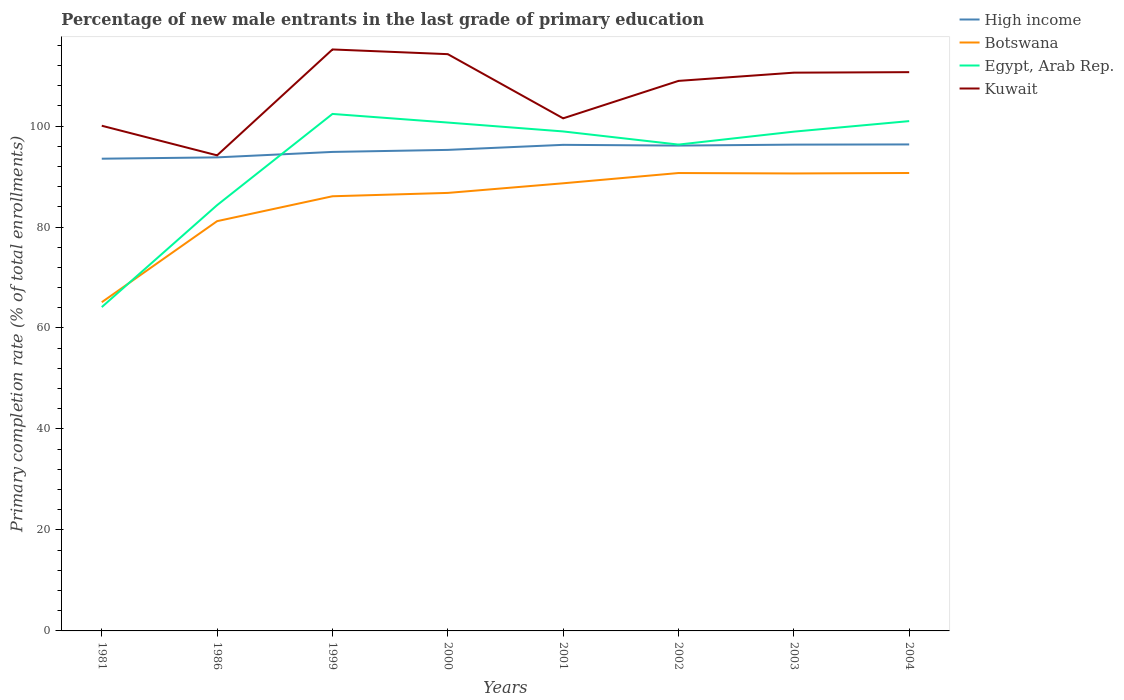How many different coloured lines are there?
Provide a succinct answer. 4. Across all years, what is the maximum percentage of new male entrants in Egypt, Arab Rep.?
Ensure brevity in your answer.  64.14. In which year was the percentage of new male entrants in Egypt, Arab Rep. maximum?
Ensure brevity in your answer.  1981. What is the total percentage of new male entrants in High income in the graph?
Give a very brief answer. -2.33. What is the difference between the highest and the second highest percentage of new male entrants in Egypt, Arab Rep.?
Give a very brief answer. 38.26. Is the percentage of new male entrants in Kuwait strictly greater than the percentage of new male entrants in High income over the years?
Keep it short and to the point. No. How many years are there in the graph?
Offer a very short reply. 8. What is the difference between two consecutive major ticks on the Y-axis?
Provide a short and direct response. 20. Does the graph contain any zero values?
Provide a succinct answer. No. Does the graph contain grids?
Provide a succinct answer. No. Where does the legend appear in the graph?
Provide a succinct answer. Top right. What is the title of the graph?
Make the answer very short. Percentage of new male entrants in the last grade of primary education. Does "Korea (Democratic)" appear as one of the legend labels in the graph?
Offer a terse response. No. What is the label or title of the Y-axis?
Keep it short and to the point. Primary completion rate (% of total enrollments). What is the Primary completion rate (% of total enrollments) in High income in 1981?
Your answer should be compact. 93.53. What is the Primary completion rate (% of total enrollments) of Botswana in 1981?
Your response must be concise. 65.1. What is the Primary completion rate (% of total enrollments) in Egypt, Arab Rep. in 1981?
Your answer should be compact. 64.14. What is the Primary completion rate (% of total enrollments) of Kuwait in 1981?
Provide a succinct answer. 100.06. What is the Primary completion rate (% of total enrollments) in High income in 1986?
Provide a succinct answer. 93.79. What is the Primary completion rate (% of total enrollments) of Botswana in 1986?
Your response must be concise. 81.16. What is the Primary completion rate (% of total enrollments) in Egypt, Arab Rep. in 1986?
Offer a terse response. 84.33. What is the Primary completion rate (% of total enrollments) in Kuwait in 1986?
Give a very brief answer. 94.19. What is the Primary completion rate (% of total enrollments) in High income in 1999?
Provide a succinct answer. 94.87. What is the Primary completion rate (% of total enrollments) in Botswana in 1999?
Keep it short and to the point. 86.09. What is the Primary completion rate (% of total enrollments) of Egypt, Arab Rep. in 1999?
Offer a terse response. 102.39. What is the Primary completion rate (% of total enrollments) of Kuwait in 1999?
Ensure brevity in your answer.  115.16. What is the Primary completion rate (% of total enrollments) of High income in 2000?
Ensure brevity in your answer.  95.27. What is the Primary completion rate (% of total enrollments) of Botswana in 2000?
Give a very brief answer. 86.75. What is the Primary completion rate (% of total enrollments) in Egypt, Arab Rep. in 2000?
Your answer should be compact. 100.69. What is the Primary completion rate (% of total enrollments) in Kuwait in 2000?
Your answer should be very brief. 114.23. What is the Primary completion rate (% of total enrollments) of High income in 2001?
Offer a very short reply. 96.27. What is the Primary completion rate (% of total enrollments) in Botswana in 2001?
Your answer should be compact. 88.66. What is the Primary completion rate (% of total enrollments) in Egypt, Arab Rep. in 2001?
Ensure brevity in your answer.  98.93. What is the Primary completion rate (% of total enrollments) in Kuwait in 2001?
Your response must be concise. 101.52. What is the Primary completion rate (% of total enrollments) in High income in 2002?
Make the answer very short. 96.13. What is the Primary completion rate (% of total enrollments) in Botswana in 2002?
Your answer should be compact. 90.69. What is the Primary completion rate (% of total enrollments) in Egypt, Arab Rep. in 2002?
Your response must be concise. 96.32. What is the Primary completion rate (% of total enrollments) of Kuwait in 2002?
Your answer should be very brief. 108.94. What is the Primary completion rate (% of total enrollments) in High income in 2003?
Provide a succinct answer. 96.32. What is the Primary completion rate (% of total enrollments) of Botswana in 2003?
Your response must be concise. 90.61. What is the Primary completion rate (% of total enrollments) in Egypt, Arab Rep. in 2003?
Provide a short and direct response. 98.89. What is the Primary completion rate (% of total enrollments) in Kuwait in 2003?
Your response must be concise. 110.57. What is the Primary completion rate (% of total enrollments) in High income in 2004?
Ensure brevity in your answer.  96.35. What is the Primary completion rate (% of total enrollments) of Botswana in 2004?
Your response must be concise. 90.7. What is the Primary completion rate (% of total enrollments) in Egypt, Arab Rep. in 2004?
Your answer should be very brief. 100.97. What is the Primary completion rate (% of total enrollments) of Kuwait in 2004?
Your response must be concise. 110.67. Across all years, what is the maximum Primary completion rate (% of total enrollments) in High income?
Ensure brevity in your answer.  96.35. Across all years, what is the maximum Primary completion rate (% of total enrollments) of Botswana?
Your answer should be very brief. 90.7. Across all years, what is the maximum Primary completion rate (% of total enrollments) of Egypt, Arab Rep.?
Give a very brief answer. 102.39. Across all years, what is the maximum Primary completion rate (% of total enrollments) in Kuwait?
Offer a terse response. 115.16. Across all years, what is the minimum Primary completion rate (% of total enrollments) in High income?
Your response must be concise. 93.53. Across all years, what is the minimum Primary completion rate (% of total enrollments) of Botswana?
Offer a very short reply. 65.1. Across all years, what is the minimum Primary completion rate (% of total enrollments) of Egypt, Arab Rep.?
Keep it short and to the point. 64.14. Across all years, what is the minimum Primary completion rate (% of total enrollments) of Kuwait?
Your response must be concise. 94.19. What is the total Primary completion rate (% of total enrollments) in High income in the graph?
Offer a very short reply. 762.53. What is the total Primary completion rate (% of total enrollments) in Botswana in the graph?
Offer a very short reply. 679.75. What is the total Primary completion rate (% of total enrollments) in Egypt, Arab Rep. in the graph?
Keep it short and to the point. 746.66. What is the total Primary completion rate (% of total enrollments) in Kuwait in the graph?
Ensure brevity in your answer.  855.35. What is the difference between the Primary completion rate (% of total enrollments) in High income in 1981 and that in 1986?
Provide a succinct answer. -0.26. What is the difference between the Primary completion rate (% of total enrollments) of Botswana in 1981 and that in 1986?
Make the answer very short. -16.06. What is the difference between the Primary completion rate (% of total enrollments) of Egypt, Arab Rep. in 1981 and that in 1986?
Offer a terse response. -20.2. What is the difference between the Primary completion rate (% of total enrollments) in Kuwait in 1981 and that in 1986?
Provide a succinct answer. 5.86. What is the difference between the Primary completion rate (% of total enrollments) of High income in 1981 and that in 1999?
Offer a terse response. -1.34. What is the difference between the Primary completion rate (% of total enrollments) in Botswana in 1981 and that in 1999?
Ensure brevity in your answer.  -20.99. What is the difference between the Primary completion rate (% of total enrollments) of Egypt, Arab Rep. in 1981 and that in 1999?
Your response must be concise. -38.26. What is the difference between the Primary completion rate (% of total enrollments) in Kuwait in 1981 and that in 1999?
Ensure brevity in your answer.  -15.11. What is the difference between the Primary completion rate (% of total enrollments) of High income in 1981 and that in 2000?
Provide a short and direct response. -1.75. What is the difference between the Primary completion rate (% of total enrollments) in Botswana in 1981 and that in 2000?
Keep it short and to the point. -21.65. What is the difference between the Primary completion rate (% of total enrollments) in Egypt, Arab Rep. in 1981 and that in 2000?
Your response must be concise. -36.55. What is the difference between the Primary completion rate (% of total enrollments) of Kuwait in 1981 and that in 2000?
Keep it short and to the point. -14.18. What is the difference between the Primary completion rate (% of total enrollments) in High income in 1981 and that in 2001?
Ensure brevity in your answer.  -2.74. What is the difference between the Primary completion rate (% of total enrollments) of Botswana in 1981 and that in 2001?
Offer a terse response. -23.55. What is the difference between the Primary completion rate (% of total enrollments) of Egypt, Arab Rep. in 1981 and that in 2001?
Your response must be concise. -34.79. What is the difference between the Primary completion rate (% of total enrollments) of Kuwait in 1981 and that in 2001?
Your answer should be compact. -1.47. What is the difference between the Primary completion rate (% of total enrollments) of High income in 1981 and that in 2002?
Your response must be concise. -2.6. What is the difference between the Primary completion rate (% of total enrollments) of Botswana in 1981 and that in 2002?
Your answer should be very brief. -25.59. What is the difference between the Primary completion rate (% of total enrollments) of Egypt, Arab Rep. in 1981 and that in 2002?
Ensure brevity in your answer.  -32.19. What is the difference between the Primary completion rate (% of total enrollments) in Kuwait in 1981 and that in 2002?
Your answer should be compact. -8.88. What is the difference between the Primary completion rate (% of total enrollments) of High income in 1981 and that in 2003?
Provide a succinct answer. -2.79. What is the difference between the Primary completion rate (% of total enrollments) of Botswana in 1981 and that in 2003?
Make the answer very short. -25.5. What is the difference between the Primary completion rate (% of total enrollments) in Egypt, Arab Rep. in 1981 and that in 2003?
Provide a succinct answer. -34.75. What is the difference between the Primary completion rate (% of total enrollments) of Kuwait in 1981 and that in 2003?
Make the answer very short. -10.51. What is the difference between the Primary completion rate (% of total enrollments) in High income in 1981 and that in 2004?
Keep it short and to the point. -2.82. What is the difference between the Primary completion rate (% of total enrollments) in Botswana in 1981 and that in 2004?
Keep it short and to the point. -25.59. What is the difference between the Primary completion rate (% of total enrollments) in Egypt, Arab Rep. in 1981 and that in 2004?
Your response must be concise. -36.84. What is the difference between the Primary completion rate (% of total enrollments) of Kuwait in 1981 and that in 2004?
Offer a terse response. -10.61. What is the difference between the Primary completion rate (% of total enrollments) of High income in 1986 and that in 1999?
Offer a very short reply. -1.08. What is the difference between the Primary completion rate (% of total enrollments) in Botswana in 1986 and that in 1999?
Provide a short and direct response. -4.93. What is the difference between the Primary completion rate (% of total enrollments) of Egypt, Arab Rep. in 1986 and that in 1999?
Provide a short and direct response. -18.06. What is the difference between the Primary completion rate (% of total enrollments) of Kuwait in 1986 and that in 1999?
Give a very brief answer. -20.97. What is the difference between the Primary completion rate (% of total enrollments) in High income in 1986 and that in 2000?
Your answer should be compact. -1.48. What is the difference between the Primary completion rate (% of total enrollments) in Botswana in 1986 and that in 2000?
Provide a short and direct response. -5.59. What is the difference between the Primary completion rate (% of total enrollments) in Egypt, Arab Rep. in 1986 and that in 2000?
Give a very brief answer. -16.35. What is the difference between the Primary completion rate (% of total enrollments) of Kuwait in 1986 and that in 2000?
Ensure brevity in your answer.  -20.04. What is the difference between the Primary completion rate (% of total enrollments) in High income in 1986 and that in 2001?
Provide a succinct answer. -2.48. What is the difference between the Primary completion rate (% of total enrollments) of Botswana in 1986 and that in 2001?
Offer a terse response. -7.5. What is the difference between the Primary completion rate (% of total enrollments) of Egypt, Arab Rep. in 1986 and that in 2001?
Ensure brevity in your answer.  -14.59. What is the difference between the Primary completion rate (% of total enrollments) in Kuwait in 1986 and that in 2001?
Make the answer very short. -7.33. What is the difference between the Primary completion rate (% of total enrollments) in High income in 1986 and that in 2002?
Your answer should be very brief. -2.33. What is the difference between the Primary completion rate (% of total enrollments) of Botswana in 1986 and that in 2002?
Make the answer very short. -9.53. What is the difference between the Primary completion rate (% of total enrollments) in Egypt, Arab Rep. in 1986 and that in 2002?
Ensure brevity in your answer.  -11.99. What is the difference between the Primary completion rate (% of total enrollments) in Kuwait in 1986 and that in 2002?
Keep it short and to the point. -14.75. What is the difference between the Primary completion rate (% of total enrollments) of High income in 1986 and that in 2003?
Offer a very short reply. -2.52. What is the difference between the Primary completion rate (% of total enrollments) in Botswana in 1986 and that in 2003?
Offer a terse response. -9.45. What is the difference between the Primary completion rate (% of total enrollments) of Egypt, Arab Rep. in 1986 and that in 2003?
Offer a very short reply. -14.55. What is the difference between the Primary completion rate (% of total enrollments) of Kuwait in 1986 and that in 2003?
Make the answer very short. -16.38. What is the difference between the Primary completion rate (% of total enrollments) in High income in 1986 and that in 2004?
Your response must be concise. -2.56. What is the difference between the Primary completion rate (% of total enrollments) in Botswana in 1986 and that in 2004?
Offer a terse response. -9.54. What is the difference between the Primary completion rate (% of total enrollments) in Egypt, Arab Rep. in 1986 and that in 2004?
Offer a very short reply. -16.64. What is the difference between the Primary completion rate (% of total enrollments) of Kuwait in 1986 and that in 2004?
Keep it short and to the point. -16.48. What is the difference between the Primary completion rate (% of total enrollments) in High income in 1999 and that in 2000?
Ensure brevity in your answer.  -0.4. What is the difference between the Primary completion rate (% of total enrollments) of Botswana in 1999 and that in 2000?
Give a very brief answer. -0.66. What is the difference between the Primary completion rate (% of total enrollments) of Egypt, Arab Rep. in 1999 and that in 2000?
Provide a short and direct response. 1.71. What is the difference between the Primary completion rate (% of total enrollments) of Kuwait in 1999 and that in 2000?
Your response must be concise. 0.93. What is the difference between the Primary completion rate (% of total enrollments) of High income in 1999 and that in 2001?
Your response must be concise. -1.4. What is the difference between the Primary completion rate (% of total enrollments) of Botswana in 1999 and that in 2001?
Your answer should be very brief. -2.57. What is the difference between the Primary completion rate (% of total enrollments) in Egypt, Arab Rep. in 1999 and that in 2001?
Keep it short and to the point. 3.47. What is the difference between the Primary completion rate (% of total enrollments) in Kuwait in 1999 and that in 2001?
Provide a succinct answer. 13.64. What is the difference between the Primary completion rate (% of total enrollments) in High income in 1999 and that in 2002?
Make the answer very short. -1.25. What is the difference between the Primary completion rate (% of total enrollments) of Botswana in 1999 and that in 2002?
Provide a short and direct response. -4.6. What is the difference between the Primary completion rate (% of total enrollments) of Egypt, Arab Rep. in 1999 and that in 2002?
Offer a terse response. 6.07. What is the difference between the Primary completion rate (% of total enrollments) in Kuwait in 1999 and that in 2002?
Your answer should be compact. 6.23. What is the difference between the Primary completion rate (% of total enrollments) of High income in 1999 and that in 2003?
Offer a very short reply. -1.45. What is the difference between the Primary completion rate (% of total enrollments) in Botswana in 1999 and that in 2003?
Keep it short and to the point. -4.52. What is the difference between the Primary completion rate (% of total enrollments) in Egypt, Arab Rep. in 1999 and that in 2003?
Your response must be concise. 3.51. What is the difference between the Primary completion rate (% of total enrollments) in Kuwait in 1999 and that in 2003?
Make the answer very short. 4.59. What is the difference between the Primary completion rate (% of total enrollments) of High income in 1999 and that in 2004?
Provide a short and direct response. -1.48. What is the difference between the Primary completion rate (% of total enrollments) in Botswana in 1999 and that in 2004?
Offer a terse response. -4.61. What is the difference between the Primary completion rate (% of total enrollments) of Egypt, Arab Rep. in 1999 and that in 2004?
Offer a terse response. 1.42. What is the difference between the Primary completion rate (% of total enrollments) of Kuwait in 1999 and that in 2004?
Provide a short and direct response. 4.49. What is the difference between the Primary completion rate (% of total enrollments) in High income in 2000 and that in 2001?
Make the answer very short. -1. What is the difference between the Primary completion rate (% of total enrollments) in Botswana in 2000 and that in 2001?
Make the answer very short. -1.91. What is the difference between the Primary completion rate (% of total enrollments) of Egypt, Arab Rep. in 2000 and that in 2001?
Make the answer very short. 1.76. What is the difference between the Primary completion rate (% of total enrollments) of Kuwait in 2000 and that in 2001?
Ensure brevity in your answer.  12.71. What is the difference between the Primary completion rate (% of total enrollments) in High income in 2000 and that in 2002?
Your answer should be very brief. -0.85. What is the difference between the Primary completion rate (% of total enrollments) in Botswana in 2000 and that in 2002?
Ensure brevity in your answer.  -3.94. What is the difference between the Primary completion rate (% of total enrollments) in Egypt, Arab Rep. in 2000 and that in 2002?
Keep it short and to the point. 4.36. What is the difference between the Primary completion rate (% of total enrollments) of Kuwait in 2000 and that in 2002?
Offer a very short reply. 5.29. What is the difference between the Primary completion rate (% of total enrollments) of High income in 2000 and that in 2003?
Give a very brief answer. -1.04. What is the difference between the Primary completion rate (% of total enrollments) in Botswana in 2000 and that in 2003?
Your answer should be compact. -3.86. What is the difference between the Primary completion rate (% of total enrollments) of Egypt, Arab Rep. in 2000 and that in 2003?
Your answer should be very brief. 1.8. What is the difference between the Primary completion rate (% of total enrollments) of Kuwait in 2000 and that in 2003?
Keep it short and to the point. 3.66. What is the difference between the Primary completion rate (% of total enrollments) of High income in 2000 and that in 2004?
Keep it short and to the point. -1.08. What is the difference between the Primary completion rate (% of total enrollments) in Botswana in 2000 and that in 2004?
Offer a terse response. -3.94. What is the difference between the Primary completion rate (% of total enrollments) in Egypt, Arab Rep. in 2000 and that in 2004?
Ensure brevity in your answer.  -0.29. What is the difference between the Primary completion rate (% of total enrollments) of Kuwait in 2000 and that in 2004?
Keep it short and to the point. 3.56. What is the difference between the Primary completion rate (% of total enrollments) in High income in 2001 and that in 2002?
Ensure brevity in your answer.  0.15. What is the difference between the Primary completion rate (% of total enrollments) of Botswana in 2001 and that in 2002?
Offer a very short reply. -2.03. What is the difference between the Primary completion rate (% of total enrollments) of Egypt, Arab Rep. in 2001 and that in 2002?
Offer a terse response. 2.6. What is the difference between the Primary completion rate (% of total enrollments) in Kuwait in 2001 and that in 2002?
Make the answer very short. -7.42. What is the difference between the Primary completion rate (% of total enrollments) in High income in 2001 and that in 2003?
Offer a terse response. -0.04. What is the difference between the Primary completion rate (% of total enrollments) of Botswana in 2001 and that in 2003?
Provide a short and direct response. -1.95. What is the difference between the Primary completion rate (% of total enrollments) in Egypt, Arab Rep. in 2001 and that in 2003?
Provide a short and direct response. 0.04. What is the difference between the Primary completion rate (% of total enrollments) of Kuwait in 2001 and that in 2003?
Ensure brevity in your answer.  -9.05. What is the difference between the Primary completion rate (% of total enrollments) of High income in 2001 and that in 2004?
Your answer should be very brief. -0.08. What is the difference between the Primary completion rate (% of total enrollments) in Botswana in 2001 and that in 2004?
Ensure brevity in your answer.  -2.04. What is the difference between the Primary completion rate (% of total enrollments) in Egypt, Arab Rep. in 2001 and that in 2004?
Give a very brief answer. -2.05. What is the difference between the Primary completion rate (% of total enrollments) of Kuwait in 2001 and that in 2004?
Offer a very short reply. -9.15. What is the difference between the Primary completion rate (% of total enrollments) in High income in 2002 and that in 2003?
Your answer should be very brief. -0.19. What is the difference between the Primary completion rate (% of total enrollments) in Botswana in 2002 and that in 2003?
Your answer should be compact. 0.08. What is the difference between the Primary completion rate (% of total enrollments) in Egypt, Arab Rep. in 2002 and that in 2003?
Your answer should be compact. -2.56. What is the difference between the Primary completion rate (% of total enrollments) in Kuwait in 2002 and that in 2003?
Offer a terse response. -1.63. What is the difference between the Primary completion rate (% of total enrollments) in High income in 2002 and that in 2004?
Ensure brevity in your answer.  -0.23. What is the difference between the Primary completion rate (% of total enrollments) in Botswana in 2002 and that in 2004?
Keep it short and to the point. -0.01. What is the difference between the Primary completion rate (% of total enrollments) of Egypt, Arab Rep. in 2002 and that in 2004?
Make the answer very short. -4.65. What is the difference between the Primary completion rate (% of total enrollments) in Kuwait in 2002 and that in 2004?
Your answer should be very brief. -1.73. What is the difference between the Primary completion rate (% of total enrollments) in High income in 2003 and that in 2004?
Provide a short and direct response. -0.04. What is the difference between the Primary completion rate (% of total enrollments) in Botswana in 2003 and that in 2004?
Your response must be concise. -0.09. What is the difference between the Primary completion rate (% of total enrollments) of Egypt, Arab Rep. in 2003 and that in 2004?
Provide a short and direct response. -2.09. What is the difference between the Primary completion rate (% of total enrollments) in Kuwait in 2003 and that in 2004?
Your answer should be very brief. -0.1. What is the difference between the Primary completion rate (% of total enrollments) in High income in 1981 and the Primary completion rate (% of total enrollments) in Botswana in 1986?
Give a very brief answer. 12.37. What is the difference between the Primary completion rate (% of total enrollments) in High income in 1981 and the Primary completion rate (% of total enrollments) in Egypt, Arab Rep. in 1986?
Keep it short and to the point. 9.2. What is the difference between the Primary completion rate (% of total enrollments) of High income in 1981 and the Primary completion rate (% of total enrollments) of Kuwait in 1986?
Your answer should be very brief. -0.66. What is the difference between the Primary completion rate (% of total enrollments) of Botswana in 1981 and the Primary completion rate (% of total enrollments) of Egypt, Arab Rep. in 1986?
Your response must be concise. -19.23. What is the difference between the Primary completion rate (% of total enrollments) of Botswana in 1981 and the Primary completion rate (% of total enrollments) of Kuwait in 1986?
Give a very brief answer. -29.09. What is the difference between the Primary completion rate (% of total enrollments) of Egypt, Arab Rep. in 1981 and the Primary completion rate (% of total enrollments) of Kuwait in 1986?
Your answer should be compact. -30.06. What is the difference between the Primary completion rate (% of total enrollments) of High income in 1981 and the Primary completion rate (% of total enrollments) of Botswana in 1999?
Keep it short and to the point. 7.44. What is the difference between the Primary completion rate (% of total enrollments) in High income in 1981 and the Primary completion rate (% of total enrollments) in Egypt, Arab Rep. in 1999?
Your response must be concise. -8.86. What is the difference between the Primary completion rate (% of total enrollments) in High income in 1981 and the Primary completion rate (% of total enrollments) in Kuwait in 1999?
Provide a short and direct response. -21.64. What is the difference between the Primary completion rate (% of total enrollments) of Botswana in 1981 and the Primary completion rate (% of total enrollments) of Egypt, Arab Rep. in 1999?
Give a very brief answer. -37.29. What is the difference between the Primary completion rate (% of total enrollments) of Botswana in 1981 and the Primary completion rate (% of total enrollments) of Kuwait in 1999?
Make the answer very short. -50.06. What is the difference between the Primary completion rate (% of total enrollments) of Egypt, Arab Rep. in 1981 and the Primary completion rate (% of total enrollments) of Kuwait in 1999?
Offer a very short reply. -51.03. What is the difference between the Primary completion rate (% of total enrollments) of High income in 1981 and the Primary completion rate (% of total enrollments) of Botswana in 2000?
Your answer should be very brief. 6.78. What is the difference between the Primary completion rate (% of total enrollments) in High income in 1981 and the Primary completion rate (% of total enrollments) in Egypt, Arab Rep. in 2000?
Give a very brief answer. -7.16. What is the difference between the Primary completion rate (% of total enrollments) in High income in 1981 and the Primary completion rate (% of total enrollments) in Kuwait in 2000?
Provide a succinct answer. -20.7. What is the difference between the Primary completion rate (% of total enrollments) of Botswana in 1981 and the Primary completion rate (% of total enrollments) of Egypt, Arab Rep. in 2000?
Offer a terse response. -35.59. What is the difference between the Primary completion rate (% of total enrollments) of Botswana in 1981 and the Primary completion rate (% of total enrollments) of Kuwait in 2000?
Offer a terse response. -49.13. What is the difference between the Primary completion rate (% of total enrollments) of Egypt, Arab Rep. in 1981 and the Primary completion rate (% of total enrollments) of Kuwait in 2000?
Offer a terse response. -50.1. What is the difference between the Primary completion rate (% of total enrollments) of High income in 1981 and the Primary completion rate (% of total enrollments) of Botswana in 2001?
Keep it short and to the point. 4.87. What is the difference between the Primary completion rate (% of total enrollments) of High income in 1981 and the Primary completion rate (% of total enrollments) of Egypt, Arab Rep. in 2001?
Your answer should be very brief. -5.4. What is the difference between the Primary completion rate (% of total enrollments) in High income in 1981 and the Primary completion rate (% of total enrollments) in Kuwait in 2001?
Provide a short and direct response. -7.99. What is the difference between the Primary completion rate (% of total enrollments) of Botswana in 1981 and the Primary completion rate (% of total enrollments) of Egypt, Arab Rep. in 2001?
Give a very brief answer. -33.82. What is the difference between the Primary completion rate (% of total enrollments) of Botswana in 1981 and the Primary completion rate (% of total enrollments) of Kuwait in 2001?
Offer a terse response. -36.42. What is the difference between the Primary completion rate (% of total enrollments) in Egypt, Arab Rep. in 1981 and the Primary completion rate (% of total enrollments) in Kuwait in 2001?
Ensure brevity in your answer.  -37.39. What is the difference between the Primary completion rate (% of total enrollments) in High income in 1981 and the Primary completion rate (% of total enrollments) in Botswana in 2002?
Offer a terse response. 2.84. What is the difference between the Primary completion rate (% of total enrollments) in High income in 1981 and the Primary completion rate (% of total enrollments) in Egypt, Arab Rep. in 2002?
Your answer should be compact. -2.79. What is the difference between the Primary completion rate (% of total enrollments) in High income in 1981 and the Primary completion rate (% of total enrollments) in Kuwait in 2002?
Give a very brief answer. -15.41. What is the difference between the Primary completion rate (% of total enrollments) in Botswana in 1981 and the Primary completion rate (% of total enrollments) in Egypt, Arab Rep. in 2002?
Make the answer very short. -31.22. What is the difference between the Primary completion rate (% of total enrollments) of Botswana in 1981 and the Primary completion rate (% of total enrollments) of Kuwait in 2002?
Keep it short and to the point. -43.84. What is the difference between the Primary completion rate (% of total enrollments) of Egypt, Arab Rep. in 1981 and the Primary completion rate (% of total enrollments) of Kuwait in 2002?
Keep it short and to the point. -44.8. What is the difference between the Primary completion rate (% of total enrollments) in High income in 1981 and the Primary completion rate (% of total enrollments) in Botswana in 2003?
Keep it short and to the point. 2.92. What is the difference between the Primary completion rate (% of total enrollments) in High income in 1981 and the Primary completion rate (% of total enrollments) in Egypt, Arab Rep. in 2003?
Your answer should be very brief. -5.36. What is the difference between the Primary completion rate (% of total enrollments) in High income in 1981 and the Primary completion rate (% of total enrollments) in Kuwait in 2003?
Your response must be concise. -17.04. What is the difference between the Primary completion rate (% of total enrollments) of Botswana in 1981 and the Primary completion rate (% of total enrollments) of Egypt, Arab Rep. in 2003?
Your response must be concise. -33.78. What is the difference between the Primary completion rate (% of total enrollments) of Botswana in 1981 and the Primary completion rate (% of total enrollments) of Kuwait in 2003?
Provide a succinct answer. -45.47. What is the difference between the Primary completion rate (% of total enrollments) in Egypt, Arab Rep. in 1981 and the Primary completion rate (% of total enrollments) in Kuwait in 2003?
Your response must be concise. -46.43. What is the difference between the Primary completion rate (% of total enrollments) in High income in 1981 and the Primary completion rate (% of total enrollments) in Botswana in 2004?
Give a very brief answer. 2.83. What is the difference between the Primary completion rate (% of total enrollments) of High income in 1981 and the Primary completion rate (% of total enrollments) of Egypt, Arab Rep. in 2004?
Provide a succinct answer. -7.45. What is the difference between the Primary completion rate (% of total enrollments) in High income in 1981 and the Primary completion rate (% of total enrollments) in Kuwait in 2004?
Your answer should be very brief. -17.14. What is the difference between the Primary completion rate (% of total enrollments) of Botswana in 1981 and the Primary completion rate (% of total enrollments) of Egypt, Arab Rep. in 2004?
Your answer should be compact. -35.87. What is the difference between the Primary completion rate (% of total enrollments) in Botswana in 1981 and the Primary completion rate (% of total enrollments) in Kuwait in 2004?
Give a very brief answer. -45.57. What is the difference between the Primary completion rate (% of total enrollments) of Egypt, Arab Rep. in 1981 and the Primary completion rate (% of total enrollments) of Kuwait in 2004?
Keep it short and to the point. -46.53. What is the difference between the Primary completion rate (% of total enrollments) of High income in 1986 and the Primary completion rate (% of total enrollments) of Botswana in 1999?
Make the answer very short. 7.7. What is the difference between the Primary completion rate (% of total enrollments) in High income in 1986 and the Primary completion rate (% of total enrollments) in Egypt, Arab Rep. in 1999?
Your answer should be very brief. -8.6. What is the difference between the Primary completion rate (% of total enrollments) in High income in 1986 and the Primary completion rate (% of total enrollments) in Kuwait in 1999?
Offer a terse response. -21.37. What is the difference between the Primary completion rate (% of total enrollments) of Botswana in 1986 and the Primary completion rate (% of total enrollments) of Egypt, Arab Rep. in 1999?
Provide a succinct answer. -21.24. What is the difference between the Primary completion rate (% of total enrollments) of Botswana in 1986 and the Primary completion rate (% of total enrollments) of Kuwait in 1999?
Your answer should be very brief. -34.01. What is the difference between the Primary completion rate (% of total enrollments) of Egypt, Arab Rep. in 1986 and the Primary completion rate (% of total enrollments) of Kuwait in 1999?
Your answer should be compact. -30.83. What is the difference between the Primary completion rate (% of total enrollments) of High income in 1986 and the Primary completion rate (% of total enrollments) of Botswana in 2000?
Provide a short and direct response. 7.04. What is the difference between the Primary completion rate (% of total enrollments) of High income in 1986 and the Primary completion rate (% of total enrollments) of Egypt, Arab Rep. in 2000?
Your answer should be compact. -6.9. What is the difference between the Primary completion rate (% of total enrollments) of High income in 1986 and the Primary completion rate (% of total enrollments) of Kuwait in 2000?
Offer a very short reply. -20.44. What is the difference between the Primary completion rate (% of total enrollments) in Botswana in 1986 and the Primary completion rate (% of total enrollments) in Egypt, Arab Rep. in 2000?
Ensure brevity in your answer.  -19.53. What is the difference between the Primary completion rate (% of total enrollments) of Botswana in 1986 and the Primary completion rate (% of total enrollments) of Kuwait in 2000?
Your response must be concise. -33.07. What is the difference between the Primary completion rate (% of total enrollments) of Egypt, Arab Rep. in 1986 and the Primary completion rate (% of total enrollments) of Kuwait in 2000?
Offer a very short reply. -29.9. What is the difference between the Primary completion rate (% of total enrollments) of High income in 1986 and the Primary completion rate (% of total enrollments) of Botswana in 2001?
Offer a terse response. 5.13. What is the difference between the Primary completion rate (% of total enrollments) in High income in 1986 and the Primary completion rate (% of total enrollments) in Egypt, Arab Rep. in 2001?
Offer a terse response. -5.14. What is the difference between the Primary completion rate (% of total enrollments) in High income in 1986 and the Primary completion rate (% of total enrollments) in Kuwait in 2001?
Your answer should be very brief. -7.73. What is the difference between the Primary completion rate (% of total enrollments) of Botswana in 1986 and the Primary completion rate (% of total enrollments) of Egypt, Arab Rep. in 2001?
Provide a short and direct response. -17.77. What is the difference between the Primary completion rate (% of total enrollments) in Botswana in 1986 and the Primary completion rate (% of total enrollments) in Kuwait in 2001?
Your answer should be compact. -20.36. What is the difference between the Primary completion rate (% of total enrollments) of Egypt, Arab Rep. in 1986 and the Primary completion rate (% of total enrollments) of Kuwait in 2001?
Your answer should be very brief. -17.19. What is the difference between the Primary completion rate (% of total enrollments) in High income in 1986 and the Primary completion rate (% of total enrollments) in Botswana in 2002?
Your response must be concise. 3.1. What is the difference between the Primary completion rate (% of total enrollments) of High income in 1986 and the Primary completion rate (% of total enrollments) of Egypt, Arab Rep. in 2002?
Keep it short and to the point. -2.53. What is the difference between the Primary completion rate (% of total enrollments) in High income in 1986 and the Primary completion rate (% of total enrollments) in Kuwait in 2002?
Your answer should be compact. -15.15. What is the difference between the Primary completion rate (% of total enrollments) in Botswana in 1986 and the Primary completion rate (% of total enrollments) in Egypt, Arab Rep. in 2002?
Your answer should be very brief. -15.16. What is the difference between the Primary completion rate (% of total enrollments) of Botswana in 1986 and the Primary completion rate (% of total enrollments) of Kuwait in 2002?
Ensure brevity in your answer.  -27.78. What is the difference between the Primary completion rate (% of total enrollments) of Egypt, Arab Rep. in 1986 and the Primary completion rate (% of total enrollments) of Kuwait in 2002?
Provide a succinct answer. -24.61. What is the difference between the Primary completion rate (% of total enrollments) of High income in 1986 and the Primary completion rate (% of total enrollments) of Botswana in 2003?
Your answer should be very brief. 3.18. What is the difference between the Primary completion rate (% of total enrollments) in High income in 1986 and the Primary completion rate (% of total enrollments) in Egypt, Arab Rep. in 2003?
Ensure brevity in your answer.  -5.09. What is the difference between the Primary completion rate (% of total enrollments) in High income in 1986 and the Primary completion rate (% of total enrollments) in Kuwait in 2003?
Provide a short and direct response. -16.78. What is the difference between the Primary completion rate (% of total enrollments) in Botswana in 1986 and the Primary completion rate (% of total enrollments) in Egypt, Arab Rep. in 2003?
Your response must be concise. -17.73. What is the difference between the Primary completion rate (% of total enrollments) of Botswana in 1986 and the Primary completion rate (% of total enrollments) of Kuwait in 2003?
Give a very brief answer. -29.41. What is the difference between the Primary completion rate (% of total enrollments) of Egypt, Arab Rep. in 1986 and the Primary completion rate (% of total enrollments) of Kuwait in 2003?
Your response must be concise. -26.24. What is the difference between the Primary completion rate (% of total enrollments) of High income in 1986 and the Primary completion rate (% of total enrollments) of Botswana in 2004?
Make the answer very short. 3.1. What is the difference between the Primary completion rate (% of total enrollments) in High income in 1986 and the Primary completion rate (% of total enrollments) in Egypt, Arab Rep. in 2004?
Keep it short and to the point. -7.18. What is the difference between the Primary completion rate (% of total enrollments) in High income in 1986 and the Primary completion rate (% of total enrollments) in Kuwait in 2004?
Your response must be concise. -16.88. What is the difference between the Primary completion rate (% of total enrollments) of Botswana in 1986 and the Primary completion rate (% of total enrollments) of Egypt, Arab Rep. in 2004?
Offer a terse response. -19.82. What is the difference between the Primary completion rate (% of total enrollments) in Botswana in 1986 and the Primary completion rate (% of total enrollments) in Kuwait in 2004?
Offer a terse response. -29.51. What is the difference between the Primary completion rate (% of total enrollments) of Egypt, Arab Rep. in 1986 and the Primary completion rate (% of total enrollments) of Kuwait in 2004?
Keep it short and to the point. -26.34. What is the difference between the Primary completion rate (% of total enrollments) in High income in 1999 and the Primary completion rate (% of total enrollments) in Botswana in 2000?
Ensure brevity in your answer.  8.12. What is the difference between the Primary completion rate (% of total enrollments) of High income in 1999 and the Primary completion rate (% of total enrollments) of Egypt, Arab Rep. in 2000?
Keep it short and to the point. -5.82. What is the difference between the Primary completion rate (% of total enrollments) in High income in 1999 and the Primary completion rate (% of total enrollments) in Kuwait in 2000?
Your response must be concise. -19.36. What is the difference between the Primary completion rate (% of total enrollments) in Botswana in 1999 and the Primary completion rate (% of total enrollments) in Egypt, Arab Rep. in 2000?
Keep it short and to the point. -14.6. What is the difference between the Primary completion rate (% of total enrollments) of Botswana in 1999 and the Primary completion rate (% of total enrollments) of Kuwait in 2000?
Offer a very short reply. -28.14. What is the difference between the Primary completion rate (% of total enrollments) in Egypt, Arab Rep. in 1999 and the Primary completion rate (% of total enrollments) in Kuwait in 2000?
Your answer should be very brief. -11.84. What is the difference between the Primary completion rate (% of total enrollments) in High income in 1999 and the Primary completion rate (% of total enrollments) in Botswana in 2001?
Your answer should be very brief. 6.21. What is the difference between the Primary completion rate (% of total enrollments) in High income in 1999 and the Primary completion rate (% of total enrollments) in Egypt, Arab Rep. in 2001?
Provide a succinct answer. -4.06. What is the difference between the Primary completion rate (% of total enrollments) of High income in 1999 and the Primary completion rate (% of total enrollments) of Kuwait in 2001?
Provide a succinct answer. -6.65. What is the difference between the Primary completion rate (% of total enrollments) of Botswana in 1999 and the Primary completion rate (% of total enrollments) of Egypt, Arab Rep. in 2001?
Offer a terse response. -12.84. What is the difference between the Primary completion rate (% of total enrollments) of Botswana in 1999 and the Primary completion rate (% of total enrollments) of Kuwait in 2001?
Your answer should be compact. -15.43. What is the difference between the Primary completion rate (% of total enrollments) of Egypt, Arab Rep. in 1999 and the Primary completion rate (% of total enrollments) of Kuwait in 2001?
Offer a very short reply. 0.87. What is the difference between the Primary completion rate (% of total enrollments) of High income in 1999 and the Primary completion rate (% of total enrollments) of Botswana in 2002?
Your answer should be very brief. 4.18. What is the difference between the Primary completion rate (% of total enrollments) in High income in 1999 and the Primary completion rate (% of total enrollments) in Egypt, Arab Rep. in 2002?
Offer a terse response. -1.45. What is the difference between the Primary completion rate (% of total enrollments) of High income in 1999 and the Primary completion rate (% of total enrollments) of Kuwait in 2002?
Your answer should be compact. -14.07. What is the difference between the Primary completion rate (% of total enrollments) in Botswana in 1999 and the Primary completion rate (% of total enrollments) in Egypt, Arab Rep. in 2002?
Provide a short and direct response. -10.23. What is the difference between the Primary completion rate (% of total enrollments) in Botswana in 1999 and the Primary completion rate (% of total enrollments) in Kuwait in 2002?
Your response must be concise. -22.85. What is the difference between the Primary completion rate (% of total enrollments) in Egypt, Arab Rep. in 1999 and the Primary completion rate (% of total enrollments) in Kuwait in 2002?
Ensure brevity in your answer.  -6.55. What is the difference between the Primary completion rate (% of total enrollments) in High income in 1999 and the Primary completion rate (% of total enrollments) in Botswana in 2003?
Provide a short and direct response. 4.26. What is the difference between the Primary completion rate (% of total enrollments) of High income in 1999 and the Primary completion rate (% of total enrollments) of Egypt, Arab Rep. in 2003?
Ensure brevity in your answer.  -4.02. What is the difference between the Primary completion rate (% of total enrollments) of High income in 1999 and the Primary completion rate (% of total enrollments) of Kuwait in 2003?
Provide a short and direct response. -15.7. What is the difference between the Primary completion rate (% of total enrollments) of Botswana in 1999 and the Primary completion rate (% of total enrollments) of Egypt, Arab Rep. in 2003?
Your answer should be very brief. -12.8. What is the difference between the Primary completion rate (% of total enrollments) in Botswana in 1999 and the Primary completion rate (% of total enrollments) in Kuwait in 2003?
Offer a terse response. -24.48. What is the difference between the Primary completion rate (% of total enrollments) of Egypt, Arab Rep. in 1999 and the Primary completion rate (% of total enrollments) of Kuwait in 2003?
Provide a succinct answer. -8.18. What is the difference between the Primary completion rate (% of total enrollments) in High income in 1999 and the Primary completion rate (% of total enrollments) in Botswana in 2004?
Provide a succinct answer. 4.18. What is the difference between the Primary completion rate (% of total enrollments) in High income in 1999 and the Primary completion rate (% of total enrollments) in Egypt, Arab Rep. in 2004?
Your response must be concise. -6.1. What is the difference between the Primary completion rate (% of total enrollments) of High income in 1999 and the Primary completion rate (% of total enrollments) of Kuwait in 2004?
Give a very brief answer. -15.8. What is the difference between the Primary completion rate (% of total enrollments) of Botswana in 1999 and the Primary completion rate (% of total enrollments) of Egypt, Arab Rep. in 2004?
Provide a succinct answer. -14.89. What is the difference between the Primary completion rate (% of total enrollments) in Botswana in 1999 and the Primary completion rate (% of total enrollments) in Kuwait in 2004?
Give a very brief answer. -24.58. What is the difference between the Primary completion rate (% of total enrollments) in Egypt, Arab Rep. in 1999 and the Primary completion rate (% of total enrollments) in Kuwait in 2004?
Keep it short and to the point. -8.28. What is the difference between the Primary completion rate (% of total enrollments) of High income in 2000 and the Primary completion rate (% of total enrollments) of Botswana in 2001?
Your answer should be compact. 6.62. What is the difference between the Primary completion rate (% of total enrollments) of High income in 2000 and the Primary completion rate (% of total enrollments) of Egypt, Arab Rep. in 2001?
Give a very brief answer. -3.65. What is the difference between the Primary completion rate (% of total enrollments) in High income in 2000 and the Primary completion rate (% of total enrollments) in Kuwait in 2001?
Your response must be concise. -6.25. What is the difference between the Primary completion rate (% of total enrollments) in Botswana in 2000 and the Primary completion rate (% of total enrollments) in Egypt, Arab Rep. in 2001?
Make the answer very short. -12.18. What is the difference between the Primary completion rate (% of total enrollments) of Botswana in 2000 and the Primary completion rate (% of total enrollments) of Kuwait in 2001?
Your answer should be very brief. -14.77. What is the difference between the Primary completion rate (% of total enrollments) of Egypt, Arab Rep. in 2000 and the Primary completion rate (% of total enrollments) of Kuwait in 2001?
Ensure brevity in your answer.  -0.84. What is the difference between the Primary completion rate (% of total enrollments) of High income in 2000 and the Primary completion rate (% of total enrollments) of Botswana in 2002?
Your response must be concise. 4.58. What is the difference between the Primary completion rate (% of total enrollments) of High income in 2000 and the Primary completion rate (% of total enrollments) of Egypt, Arab Rep. in 2002?
Keep it short and to the point. -1.05. What is the difference between the Primary completion rate (% of total enrollments) in High income in 2000 and the Primary completion rate (% of total enrollments) in Kuwait in 2002?
Make the answer very short. -13.67. What is the difference between the Primary completion rate (% of total enrollments) of Botswana in 2000 and the Primary completion rate (% of total enrollments) of Egypt, Arab Rep. in 2002?
Your response must be concise. -9.57. What is the difference between the Primary completion rate (% of total enrollments) in Botswana in 2000 and the Primary completion rate (% of total enrollments) in Kuwait in 2002?
Your response must be concise. -22.19. What is the difference between the Primary completion rate (% of total enrollments) of Egypt, Arab Rep. in 2000 and the Primary completion rate (% of total enrollments) of Kuwait in 2002?
Offer a very short reply. -8.25. What is the difference between the Primary completion rate (% of total enrollments) of High income in 2000 and the Primary completion rate (% of total enrollments) of Botswana in 2003?
Give a very brief answer. 4.67. What is the difference between the Primary completion rate (% of total enrollments) in High income in 2000 and the Primary completion rate (% of total enrollments) in Egypt, Arab Rep. in 2003?
Provide a succinct answer. -3.61. What is the difference between the Primary completion rate (% of total enrollments) in High income in 2000 and the Primary completion rate (% of total enrollments) in Kuwait in 2003?
Give a very brief answer. -15.3. What is the difference between the Primary completion rate (% of total enrollments) in Botswana in 2000 and the Primary completion rate (% of total enrollments) in Egypt, Arab Rep. in 2003?
Provide a short and direct response. -12.13. What is the difference between the Primary completion rate (% of total enrollments) in Botswana in 2000 and the Primary completion rate (% of total enrollments) in Kuwait in 2003?
Your answer should be very brief. -23.82. What is the difference between the Primary completion rate (% of total enrollments) of Egypt, Arab Rep. in 2000 and the Primary completion rate (% of total enrollments) of Kuwait in 2003?
Your answer should be compact. -9.88. What is the difference between the Primary completion rate (% of total enrollments) of High income in 2000 and the Primary completion rate (% of total enrollments) of Botswana in 2004?
Give a very brief answer. 4.58. What is the difference between the Primary completion rate (% of total enrollments) of High income in 2000 and the Primary completion rate (% of total enrollments) of Egypt, Arab Rep. in 2004?
Provide a succinct answer. -5.7. What is the difference between the Primary completion rate (% of total enrollments) of High income in 2000 and the Primary completion rate (% of total enrollments) of Kuwait in 2004?
Offer a terse response. -15.4. What is the difference between the Primary completion rate (% of total enrollments) in Botswana in 2000 and the Primary completion rate (% of total enrollments) in Egypt, Arab Rep. in 2004?
Provide a short and direct response. -14.22. What is the difference between the Primary completion rate (% of total enrollments) in Botswana in 2000 and the Primary completion rate (% of total enrollments) in Kuwait in 2004?
Your answer should be compact. -23.92. What is the difference between the Primary completion rate (% of total enrollments) in Egypt, Arab Rep. in 2000 and the Primary completion rate (% of total enrollments) in Kuwait in 2004?
Offer a very short reply. -9.98. What is the difference between the Primary completion rate (% of total enrollments) in High income in 2001 and the Primary completion rate (% of total enrollments) in Botswana in 2002?
Your answer should be compact. 5.58. What is the difference between the Primary completion rate (% of total enrollments) in High income in 2001 and the Primary completion rate (% of total enrollments) in Egypt, Arab Rep. in 2002?
Provide a short and direct response. -0.05. What is the difference between the Primary completion rate (% of total enrollments) in High income in 2001 and the Primary completion rate (% of total enrollments) in Kuwait in 2002?
Make the answer very short. -12.67. What is the difference between the Primary completion rate (% of total enrollments) in Botswana in 2001 and the Primary completion rate (% of total enrollments) in Egypt, Arab Rep. in 2002?
Provide a succinct answer. -7.67. What is the difference between the Primary completion rate (% of total enrollments) in Botswana in 2001 and the Primary completion rate (% of total enrollments) in Kuwait in 2002?
Offer a terse response. -20.28. What is the difference between the Primary completion rate (% of total enrollments) in Egypt, Arab Rep. in 2001 and the Primary completion rate (% of total enrollments) in Kuwait in 2002?
Offer a terse response. -10.01. What is the difference between the Primary completion rate (% of total enrollments) of High income in 2001 and the Primary completion rate (% of total enrollments) of Botswana in 2003?
Offer a terse response. 5.67. What is the difference between the Primary completion rate (% of total enrollments) in High income in 2001 and the Primary completion rate (% of total enrollments) in Egypt, Arab Rep. in 2003?
Make the answer very short. -2.61. What is the difference between the Primary completion rate (% of total enrollments) in High income in 2001 and the Primary completion rate (% of total enrollments) in Kuwait in 2003?
Make the answer very short. -14.3. What is the difference between the Primary completion rate (% of total enrollments) of Botswana in 2001 and the Primary completion rate (% of total enrollments) of Egypt, Arab Rep. in 2003?
Your answer should be compact. -10.23. What is the difference between the Primary completion rate (% of total enrollments) of Botswana in 2001 and the Primary completion rate (% of total enrollments) of Kuwait in 2003?
Give a very brief answer. -21.91. What is the difference between the Primary completion rate (% of total enrollments) in Egypt, Arab Rep. in 2001 and the Primary completion rate (% of total enrollments) in Kuwait in 2003?
Provide a succinct answer. -11.64. What is the difference between the Primary completion rate (% of total enrollments) in High income in 2001 and the Primary completion rate (% of total enrollments) in Botswana in 2004?
Make the answer very short. 5.58. What is the difference between the Primary completion rate (% of total enrollments) of High income in 2001 and the Primary completion rate (% of total enrollments) of Egypt, Arab Rep. in 2004?
Keep it short and to the point. -4.7. What is the difference between the Primary completion rate (% of total enrollments) in High income in 2001 and the Primary completion rate (% of total enrollments) in Kuwait in 2004?
Provide a short and direct response. -14.4. What is the difference between the Primary completion rate (% of total enrollments) of Botswana in 2001 and the Primary completion rate (% of total enrollments) of Egypt, Arab Rep. in 2004?
Provide a short and direct response. -12.32. What is the difference between the Primary completion rate (% of total enrollments) of Botswana in 2001 and the Primary completion rate (% of total enrollments) of Kuwait in 2004?
Make the answer very short. -22.01. What is the difference between the Primary completion rate (% of total enrollments) in Egypt, Arab Rep. in 2001 and the Primary completion rate (% of total enrollments) in Kuwait in 2004?
Ensure brevity in your answer.  -11.74. What is the difference between the Primary completion rate (% of total enrollments) of High income in 2002 and the Primary completion rate (% of total enrollments) of Botswana in 2003?
Offer a terse response. 5.52. What is the difference between the Primary completion rate (% of total enrollments) of High income in 2002 and the Primary completion rate (% of total enrollments) of Egypt, Arab Rep. in 2003?
Provide a short and direct response. -2.76. What is the difference between the Primary completion rate (% of total enrollments) in High income in 2002 and the Primary completion rate (% of total enrollments) in Kuwait in 2003?
Provide a succinct answer. -14.44. What is the difference between the Primary completion rate (% of total enrollments) of Botswana in 2002 and the Primary completion rate (% of total enrollments) of Egypt, Arab Rep. in 2003?
Offer a very short reply. -8.2. What is the difference between the Primary completion rate (% of total enrollments) of Botswana in 2002 and the Primary completion rate (% of total enrollments) of Kuwait in 2003?
Make the answer very short. -19.88. What is the difference between the Primary completion rate (% of total enrollments) in Egypt, Arab Rep. in 2002 and the Primary completion rate (% of total enrollments) in Kuwait in 2003?
Offer a terse response. -14.25. What is the difference between the Primary completion rate (% of total enrollments) in High income in 2002 and the Primary completion rate (% of total enrollments) in Botswana in 2004?
Offer a very short reply. 5.43. What is the difference between the Primary completion rate (% of total enrollments) of High income in 2002 and the Primary completion rate (% of total enrollments) of Egypt, Arab Rep. in 2004?
Ensure brevity in your answer.  -4.85. What is the difference between the Primary completion rate (% of total enrollments) of High income in 2002 and the Primary completion rate (% of total enrollments) of Kuwait in 2004?
Provide a short and direct response. -14.54. What is the difference between the Primary completion rate (% of total enrollments) of Botswana in 2002 and the Primary completion rate (% of total enrollments) of Egypt, Arab Rep. in 2004?
Your response must be concise. -10.28. What is the difference between the Primary completion rate (% of total enrollments) of Botswana in 2002 and the Primary completion rate (% of total enrollments) of Kuwait in 2004?
Your answer should be very brief. -19.98. What is the difference between the Primary completion rate (% of total enrollments) of Egypt, Arab Rep. in 2002 and the Primary completion rate (% of total enrollments) of Kuwait in 2004?
Your answer should be very brief. -14.35. What is the difference between the Primary completion rate (% of total enrollments) of High income in 2003 and the Primary completion rate (% of total enrollments) of Botswana in 2004?
Provide a succinct answer. 5.62. What is the difference between the Primary completion rate (% of total enrollments) in High income in 2003 and the Primary completion rate (% of total enrollments) in Egypt, Arab Rep. in 2004?
Keep it short and to the point. -4.66. What is the difference between the Primary completion rate (% of total enrollments) of High income in 2003 and the Primary completion rate (% of total enrollments) of Kuwait in 2004?
Provide a short and direct response. -14.35. What is the difference between the Primary completion rate (% of total enrollments) of Botswana in 2003 and the Primary completion rate (% of total enrollments) of Egypt, Arab Rep. in 2004?
Ensure brevity in your answer.  -10.37. What is the difference between the Primary completion rate (% of total enrollments) in Botswana in 2003 and the Primary completion rate (% of total enrollments) in Kuwait in 2004?
Give a very brief answer. -20.06. What is the difference between the Primary completion rate (% of total enrollments) of Egypt, Arab Rep. in 2003 and the Primary completion rate (% of total enrollments) of Kuwait in 2004?
Provide a succinct answer. -11.78. What is the average Primary completion rate (% of total enrollments) of High income per year?
Keep it short and to the point. 95.32. What is the average Primary completion rate (% of total enrollments) of Botswana per year?
Give a very brief answer. 84.97. What is the average Primary completion rate (% of total enrollments) in Egypt, Arab Rep. per year?
Provide a short and direct response. 93.33. What is the average Primary completion rate (% of total enrollments) in Kuwait per year?
Your answer should be compact. 106.92. In the year 1981, what is the difference between the Primary completion rate (% of total enrollments) of High income and Primary completion rate (% of total enrollments) of Botswana?
Your response must be concise. 28.43. In the year 1981, what is the difference between the Primary completion rate (% of total enrollments) in High income and Primary completion rate (% of total enrollments) in Egypt, Arab Rep.?
Give a very brief answer. 29.39. In the year 1981, what is the difference between the Primary completion rate (% of total enrollments) of High income and Primary completion rate (% of total enrollments) of Kuwait?
Make the answer very short. -6.53. In the year 1981, what is the difference between the Primary completion rate (% of total enrollments) of Botswana and Primary completion rate (% of total enrollments) of Egypt, Arab Rep.?
Provide a short and direct response. 0.97. In the year 1981, what is the difference between the Primary completion rate (% of total enrollments) of Botswana and Primary completion rate (% of total enrollments) of Kuwait?
Your response must be concise. -34.96. In the year 1981, what is the difference between the Primary completion rate (% of total enrollments) in Egypt, Arab Rep. and Primary completion rate (% of total enrollments) in Kuwait?
Provide a short and direct response. -35.92. In the year 1986, what is the difference between the Primary completion rate (% of total enrollments) of High income and Primary completion rate (% of total enrollments) of Botswana?
Your answer should be compact. 12.63. In the year 1986, what is the difference between the Primary completion rate (% of total enrollments) of High income and Primary completion rate (% of total enrollments) of Egypt, Arab Rep.?
Offer a very short reply. 9.46. In the year 1986, what is the difference between the Primary completion rate (% of total enrollments) of High income and Primary completion rate (% of total enrollments) of Kuwait?
Offer a very short reply. -0.4. In the year 1986, what is the difference between the Primary completion rate (% of total enrollments) in Botswana and Primary completion rate (% of total enrollments) in Egypt, Arab Rep.?
Ensure brevity in your answer.  -3.17. In the year 1986, what is the difference between the Primary completion rate (% of total enrollments) in Botswana and Primary completion rate (% of total enrollments) in Kuwait?
Make the answer very short. -13.03. In the year 1986, what is the difference between the Primary completion rate (% of total enrollments) of Egypt, Arab Rep. and Primary completion rate (% of total enrollments) of Kuwait?
Ensure brevity in your answer.  -9.86. In the year 1999, what is the difference between the Primary completion rate (% of total enrollments) in High income and Primary completion rate (% of total enrollments) in Botswana?
Keep it short and to the point. 8.78. In the year 1999, what is the difference between the Primary completion rate (% of total enrollments) of High income and Primary completion rate (% of total enrollments) of Egypt, Arab Rep.?
Provide a short and direct response. -7.52. In the year 1999, what is the difference between the Primary completion rate (% of total enrollments) of High income and Primary completion rate (% of total enrollments) of Kuwait?
Provide a succinct answer. -20.29. In the year 1999, what is the difference between the Primary completion rate (% of total enrollments) in Botswana and Primary completion rate (% of total enrollments) in Egypt, Arab Rep.?
Your response must be concise. -16.31. In the year 1999, what is the difference between the Primary completion rate (% of total enrollments) in Botswana and Primary completion rate (% of total enrollments) in Kuwait?
Offer a very short reply. -29.08. In the year 1999, what is the difference between the Primary completion rate (% of total enrollments) in Egypt, Arab Rep. and Primary completion rate (% of total enrollments) in Kuwait?
Your answer should be compact. -12.77. In the year 2000, what is the difference between the Primary completion rate (% of total enrollments) of High income and Primary completion rate (% of total enrollments) of Botswana?
Provide a succinct answer. 8.52. In the year 2000, what is the difference between the Primary completion rate (% of total enrollments) of High income and Primary completion rate (% of total enrollments) of Egypt, Arab Rep.?
Offer a very short reply. -5.41. In the year 2000, what is the difference between the Primary completion rate (% of total enrollments) of High income and Primary completion rate (% of total enrollments) of Kuwait?
Provide a short and direct response. -18.96. In the year 2000, what is the difference between the Primary completion rate (% of total enrollments) in Botswana and Primary completion rate (% of total enrollments) in Egypt, Arab Rep.?
Make the answer very short. -13.94. In the year 2000, what is the difference between the Primary completion rate (% of total enrollments) in Botswana and Primary completion rate (% of total enrollments) in Kuwait?
Ensure brevity in your answer.  -27.48. In the year 2000, what is the difference between the Primary completion rate (% of total enrollments) of Egypt, Arab Rep. and Primary completion rate (% of total enrollments) of Kuwait?
Make the answer very short. -13.55. In the year 2001, what is the difference between the Primary completion rate (% of total enrollments) of High income and Primary completion rate (% of total enrollments) of Botswana?
Your response must be concise. 7.62. In the year 2001, what is the difference between the Primary completion rate (% of total enrollments) of High income and Primary completion rate (% of total enrollments) of Egypt, Arab Rep.?
Offer a very short reply. -2.65. In the year 2001, what is the difference between the Primary completion rate (% of total enrollments) of High income and Primary completion rate (% of total enrollments) of Kuwait?
Provide a succinct answer. -5.25. In the year 2001, what is the difference between the Primary completion rate (% of total enrollments) of Botswana and Primary completion rate (% of total enrollments) of Egypt, Arab Rep.?
Keep it short and to the point. -10.27. In the year 2001, what is the difference between the Primary completion rate (% of total enrollments) of Botswana and Primary completion rate (% of total enrollments) of Kuwait?
Provide a succinct answer. -12.87. In the year 2001, what is the difference between the Primary completion rate (% of total enrollments) in Egypt, Arab Rep. and Primary completion rate (% of total enrollments) in Kuwait?
Make the answer very short. -2.6. In the year 2002, what is the difference between the Primary completion rate (% of total enrollments) in High income and Primary completion rate (% of total enrollments) in Botswana?
Give a very brief answer. 5.43. In the year 2002, what is the difference between the Primary completion rate (% of total enrollments) of High income and Primary completion rate (% of total enrollments) of Egypt, Arab Rep.?
Give a very brief answer. -0.2. In the year 2002, what is the difference between the Primary completion rate (% of total enrollments) of High income and Primary completion rate (% of total enrollments) of Kuwait?
Give a very brief answer. -12.81. In the year 2002, what is the difference between the Primary completion rate (% of total enrollments) of Botswana and Primary completion rate (% of total enrollments) of Egypt, Arab Rep.?
Ensure brevity in your answer.  -5.63. In the year 2002, what is the difference between the Primary completion rate (% of total enrollments) in Botswana and Primary completion rate (% of total enrollments) in Kuwait?
Your answer should be very brief. -18.25. In the year 2002, what is the difference between the Primary completion rate (% of total enrollments) of Egypt, Arab Rep. and Primary completion rate (% of total enrollments) of Kuwait?
Offer a very short reply. -12.62. In the year 2003, what is the difference between the Primary completion rate (% of total enrollments) of High income and Primary completion rate (% of total enrollments) of Botswana?
Provide a short and direct response. 5.71. In the year 2003, what is the difference between the Primary completion rate (% of total enrollments) in High income and Primary completion rate (% of total enrollments) in Egypt, Arab Rep.?
Keep it short and to the point. -2.57. In the year 2003, what is the difference between the Primary completion rate (% of total enrollments) in High income and Primary completion rate (% of total enrollments) in Kuwait?
Give a very brief answer. -14.25. In the year 2003, what is the difference between the Primary completion rate (% of total enrollments) of Botswana and Primary completion rate (% of total enrollments) of Egypt, Arab Rep.?
Offer a terse response. -8.28. In the year 2003, what is the difference between the Primary completion rate (% of total enrollments) of Botswana and Primary completion rate (% of total enrollments) of Kuwait?
Your response must be concise. -19.96. In the year 2003, what is the difference between the Primary completion rate (% of total enrollments) of Egypt, Arab Rep. and Primary completion rate (% of total enrollments) of Kuwait?
Make the answer very short. -11.68. In the year 2004, what is the difference between the Primary completion rate (% of total enrollments) of High income and Primary completion rate (% of total enrollments) of Botswana?
Keep it short and to the point. 5.66. In the year 2004, what is the difference between the Primary completion rate (% of total enrollments) of High income and Primary completion rate (% of total enrollments) of Egypt, Arab Rep.?
Provide a succinct answer. -4.62. In the year 2004, what is the difference between the Primary completion rate (% of total enrollments) of High income and Primary completion rate (% of total enrollments) of Kuwait?
Offer a terse response. -14.32. In the year 2004, what is the difference between the Primary completion rate (% of total enrollments) in Botswana and Primary completion rate (% of total enrollments) in Egypt, Arab Rep.?
Give a very brief answer. -10.28. In the year 2004, what is the difference between the Primary completion rate (% of total enrollments) of Botswana and Primary completion rate (% of total enrollments) of Kuwait?
Your response must be concise. -19.97. In the year 2004, what is the difference between the Primary completion rate (% of total enrollments) in Egypt, Arab Rep. and Primary completion rate (% of total enrollments) in Kuwait?
Provide a short and direct response. -9.7. What is the ratio of the Primary completion rate (% of total enrollments) of Botswana in 1981 to that in 1986?
Your answer should be very brief. 0.8. What is the ratio of the Primary completion rate (% of total enrollments) of Egypt, Arab Rep. in 1981 to that in 1986?
Ensure brevity in your answer.  0.76. What is the ratio of the Primary completion rate (% of total enrollments) in Kuwait in 1981 to that in 1986?
Provide a short and direct response. 1.06. What is the ratio of the Primary completion rate (% of total enrollments) of High income in 1981 to that in 1999?
Your response must be concise. 0.99. What is the ratio of the Primary completion rate (% of total enrollments) of Botswana in 1981 to that in 1999?
Keep it short and to the point. 0.76. What is the ratio of the Primary completion rate (% of total enrollments) in Egypt, Arab Rep. in 1981 to that in 1999?
Your answer should be compact. 0.63. What is the ratio of the Primary completion rate (% of total enrollments) in Kuwait in 1981 to that in 1999?
Ensure brevity in your answer.  0.87. What is the ratio of the Primary completion rate (% of total enrollments) in High income in 1981 to that in 2000?
Offer a very short reply. 0.98. What is the ratio of the Primary completion rate (% of total enrollments) in Botswana in 1981 to that in 2000?
Ensure brevity in your answer.  0.75. What is the ratio of the Primary completion rate (% of total enrollments) of Egypt, Arab Rep. in 1981 to that in 2000?
Keep it short and to the point. 0.64. What is the ratio of the Primary completion rate (% of total enrollments) in Kuwait in 1981 to that in 2000?
Your response must be concise. 0.88. What is the ratio of the Primary completion rate (% of total enrollments) in High income in 1981 to that in 2001?
Your answer should be very brief. 0.97. What is the ratio of the Primary completion rate (% of total enrollments) in Botswana in 1981 to that in 2001?
Your answer should be compact. 0.73. What is the ratio of the Primary completion rate (% of total enrollments) in Egypt, Arab Rep. in 1981 to that in 2001?
Ensure brevity in your answer.  0.65. What is the ratio of the Primary completion rate (% of total enrollments) in Kuwait in 1981 to that in 2001?
Your answer should be very brief. 0.99. What is the ratio of the Primary completion rate (% of total enrollments) of Botswana in 1981 to that in 2002?
Provide a succinct answer. 0.72. What is the ratio of the Primary completion rate (% of total enrollments) in Egypt, Arab Rep. in 1981 to that in 2002?
Ensure brevity in your answer.  0.67. What is the ratio of the Primary completion rate (% of total enrollments) in Kuwait in 1981 to that in 2002?
Offer a terse response. 0.92. What is the ratio of the Primary completion rate (% of total enrollments) of High income in 1981 to that in 2003?
Make the answer very short. 0.97. What is the ratio of the Primary completion rate (% of total enrollments) of Botswana in 1981 to that in 2003?
Your response must be concise. 0.72. What is the ratio of the Primary completion rate (% of total enrollments) in Egypt, Arab Rep. in 1981 to that in 2003?
Provide a succinct answer. 0.65. What is the ratio of the Primary completion rate (% of total enrollments) of Kuwait in 1981 to that in 2003?
Offer a terse response. 0.9. What is the ratio of the Primary completion rate (% of total enrollments) of High income in 1981 to that in 2004?
Offer a very short reply. 0.97. What is the ratio of the Primary completion rate (% of total enrollments) of Botswana in 1981 to that in 2004?
Offer a very short reply. 0.72. What is the ratio of the Primary completion rate (% of total enrollments) of Egypt, Arab Rep. in 1981 to that in 2004?
Keep it short and to the point. 0.64. What is the ratio of the Primary completion rate (% of total enrollments) of Kuwait in 1981 to that in 2004?
Your answer should be compact. 0.9. What is the ratio of the Primary completion rate (% of total enrollments) in Botswana in 1986 to that in 1999?
Make the answer very short. 0.94. What is the ratio of the Primary completion rate (% of total enrollments) in Egypt, Arab Rep. in 1986 to that in 1999?
Give a very brief answer. 0.82. What is the ratio of the Primary completion rate (% of total enrollments) in Kuwait in 1986 to that in 1999?
Make the answer very short. 0.82. What is the ratio of the Primary completion rate (% of total enrollments) of High income in 1986 to that in 2000?
Your answer should be very brief. 0.98. What is the ratio of the Primary completion rate (% of total enrollments) in Botswana in 1986 to that in 2000?
Ensure brevity in your answer.  0.94. What is the ratio of the Primary completion rate (% of total enrollments) in Egypt, Arab Rep. in 1986 to that in 2000?
Give a very brief answer. 0.84. What is the ratio of the Primary completion rate (% of total enrollments) of Kuwait in 1986 to that in 2000?
Your response must be concise. 0.82. What is the ratio of the Primary completion rate (% of total enrollments) of High income in 1986 to that in 2001?
Offer a very short reply. 0.97. What is the ratio of the Primary completion rate (% of total enrollments) of Botswana in 1986 to that in 2001?
Keep it short and to the point. 0.92. What is the ratio of the Primary completion rate (% of total enrollments) of Egypt, Arab Rep. in 1986 to that in 2001?
Your answer should be compact. 0.85. What is the ratio of the Primary completion rate (% of total enrollments) of Kuwait in 1986 to that in 2001?
Offer a terse response. 0.93. What is the ratio of the Primary completion rate (% of total enrollments) in High income in 1986 to that in 2002?
Keep it short and to the point. 0.98. What is the ratio of the Primary completion rate (% of total enrollments) in Botswana in 1986 to that in 2002?
Your response must be concise. 0.89. What is the ratio of the Primary completion rate (% of total enrollments) of Egypt, Arab Rep. in 1986 to that in 2002?
Offer a terse response. 0.88. What is the ratio of the Primary completion rate (% of total enrollments) in Kuwait in 1986 to that in 2002?
Provide a short and direct response. 0.86. What is the ratio of the Primary completion rate (% of total enrollments) of High income in 1986 to that in 2003?
Provide a succinct answer. 0.97. What is the ratio of the Primary completion rate (% of total enrollments) of Botswana in 1986 to that in 2003?
Your answer should be compact. 0.9. What is the ratio of the Primary completion rate (% of total enrollments) in Egypt, Arab Rep. in 1986 to that in 2003?
Your answer should be compact. 0.85. What is the ratio of the Primary completion rate (% of total enrollments) in Kuwait in 1986 to that in 2003?
Provide a short and direct response. 0.85. What is the ratio of the Primary completion rate (% of total enrollments) of High income in 1986 to that in 2004?
Provide a short and direct response. 0.97. What is the ratio of the Primary completion rate (% of total enrollments) in Botswana in 1986 to that in 2004?
Make the answer very short. 0.89. What is the ratio of the Primary completion rate (% of total enrollments) of Egypt, Arab Rep. in 1986 to that in 2004?
Provide a short and direct response. 0.84. What is the ratio of the Primary completion rate (% of total enrollments) of Kuwait in 1986 to that in 2004?
Offer a very short reply. 0.85. What is the ratio of the Primary completion rate (% of total enrollments) in High income in 1999 to that in 2000?
Make the answer very short. 1. What is the ratio of the Primary completion rate (% of total enrollments) of Botswana in 1999 to that in 2000?
Your answer should be compact. 0.99. What is the ratio of the Primary completion rate (% of total enrollments) of Egypt, Arab Rep. in 1999 to that in 2000?
Your response must be concise. 1.02. What is the ratio of the Primary completion rate (% of total enrollments) in Kuwait in 1999 to that in 2000?
Provide a short and direct response. 1.01. What is the ratio of the Primary completion rate (% of total enrollments) in High income in 1999 to that in 2001?
Your answer should be compact. 0.99. What is the ratio of the Primary completion rate (% of total enrollments) of Egypt, Arab Rep. in 1999 to that in 2001?
Ensure brevity in your answer.  1.03. What is the ratio of the Primary completion rate (% of total enrollments) of Kuwait in 1999 to that in 2001?
Provide a succinct answer. 1.13. What is the ratio of the Primary completion rate (% of total enrollments) in High income in 1999 to that in 2002?
Give a very brief answer. 0.99. What is the ratio of the Primary completion rate (% of total enrollments) in Botswana in 1999 to that in 2002?
Ensure brevity in your answer.  0.95. What is the ratio of the Primary completion rate (% of total enrollments) of Egypt, Arab Rep. in 1999 to that in 2002?
Your response must be concise. 1.06. What is the ratio of the Primary completion rate (% of total enrollments) of Kuwait in 1999 to that in 2002?
Offer a very short reply. 1.06. What is the ratio of the Primary completion rate (% of total enrollments) in Botswana in 1999 to that in 2003?
Your response must be concise. 0.95. What is the ratio of the Primary completion rate (% of total enrollments) of Egypt, Arab Rep. in 1999 to that in 2003?
Your response must be concise. 1.04. What is the ratio of the Primary completion rate (% of total enrollments) of Kuwait in 1999 to that in 2003?
Your answer should be compact. 1.04. What is the ratio of the Primary completion rate (% of total enrollments) in High income in 1999 to that in 2004?
Your answer should be very brief. 0.98. What is the ratio of the Primary completion rate (% of total enrollments) in Botswana in 1999 to that in 2004?
Offer a very short reply. 0.95. What is the ratio of the Primary completion rate (% of total enrollments) of Egypt, Arab Rep. in 1999 to that in 2004?
Provide a short and direct response. 1.01. What is the ratio of the Primary completion rate (% of total enrollments) of Kuwait in 1999 to that in 2004?
Make the answer very short. 1.04. What is the ratio of the Primary completion rate (% of total enrollments) of High income in 2000 to that in 2001?
Your answer should be very brief. 0.99. What is the ratio of the Primary completion rate (% of total enrollments) in Botswana in 2000 to that in 2001?
Provide a succinct answer. 0.98. What is the ratio of the Primary completion rate (% of total enrollments) in Egypt, Arab Rep. in 2000 to that in 2001?
Make the answer very short. 1.02. What is the ratio of the Primary completion rate (% of total enrollments) of Kuwait in 2000 to that in 2001?
Make the answer very short. 1.13. What is the ratio of the Primary completion rate (% of total enrollments) of Botswana in 2000 to that in 2002?
Keep it short and to the point. 0.96. What is the ratio of the Primary completion rate (% of total enrollments) of Egypt, Arab Rep. in 2000 to that in 2002?
Keep it short and to the point. 1.05. What is the ratio of the Primary completion rate (% of total enrollments) of Kuwait in 2000 to that in 2002?
Offer a very short reply. 1.05. What is the ratio of the Primary completion rate (% of total enrollments) in Botswana in 2000 to that in 2003?
Provide a short and direct response. 0.96. What is the ratio of the Primary completion rate (% of total enrollments) in Egypt, Arab Rep. in 2000 to that in 2003?
Ensure brevity in your answer.  1.02. What is the ratio of the Primary completion rate (% of total enrollments) of Kuwait in 2000 to that in 2003?
Your answer should be compact. 1.03. What is the ratio of the Primary completion rate (% of total enrollments) in High income in 2000 to that in 2004?
Keep it short and to the point. 0.99. What is the ratio of the Primary completion rate (% of total enrollments) in Botswana in 2000 to that in 2004?
Your answer should be compact. 0.96. What is the ratio of the Primary completion rate (% of total enrollments) of Egypt, Arab Rep. in 2000 to that in 2004?
Your answer should be compact. 1. What is the ratio of the Primary completion rate (% of total enrollments) of Kuwait in 2000 to that in 2004?
Ensure brevity in your answer.  1.03. What is the ratio of the Primary completion rate (% of total enrollments) of High income in 2001 to that in 2002?
Offer a terse response. 1. What is the ratio of the Primary completion rate (% of total enrollments) of Botswana in 2001 to that in 2002?
Ensure brevity in your answer.  0.98. What is the ratio of the Primary completion rate (% of total enrollments) in Egypt, Arab Rep. in 2001 to that in 2002?
Offer a terse response. 1.03. What is the ratio of the Primary completion rate (% of total enrollments) in Kuwait in 2001 to that in 2002?
Ensure brevity in your answer.  0.93. What is the ratio of the Primary completion rate (% of total enrollments) in Botswana in 2001 to that in 2003?
Ensure brevity in your answer.  0.98. What is the ratio of the Primary completion rate (% of total enrollments) of Kuwait in 2001 to that in 2003?
Give a very brief answer. 0.92. What is the ratio of the Primary completion rate (% of total enrollments) of Botswana in 2001 to that in 2004?
Your answer should be compact. 0.98. What is the ratio of the Primary completion rate (% of total enrollments) in Egypt, Arab Rep. in 2001 to that in 2004?
Provide a short and direct response. 0.98. What is the ratio of the Primary completion rate (% of total enrollments) of Kuwait in 2001 to that in 2004?
Your response must be concise. 0.92. What is the ratio of the Primary completion rate (% of total enrollments) in Botswana in 2002 to that in 2003?
Give a very brief answer. 1. What is the ratio of the Primary completion rate (% of total enrollments) of Egypt, Arab Rep. in 2002 to that in 2003?
Offer a very short reply. 0.97. What is the ratio of the Primary completion rate (% of total enrollments) in Kuwait in 2002 to that in 2003?
Provide a short and direct response. 0.99. What is the ratio of the Primary completion rate (% of total enrollments) of High income in 2002 to that in 2004?
Ensure brevity in your answer.  1. What is the ratio of the Primary completion rate (% of total enrollments) in Botswana in 2002 to that in 2004?
Offer a very short reply. 1. What is the ratio of the Primary completion rate (% of total enrollments) in Egypt, Arab Rep. in 2002 to that in 2004?
Provide a short and direct response. 0.95. What is the ratio of the Primary completion rate (% of total enrollments) in Kuwait in 2002 to that in 2004?
Your answer should be very brief. 0.98. What is the ratio of the Primary completion rate (% of total enrollments) in Egypt, Arab Rep. in 2003 to that in 2004?
Your response must be concise. 0.98. What is the ratio of the Primary completion rate (% of total enrollments) of Kuwait in 2003 to that in 2004?
Your response must be concise. 1. What is the difference between the highest and the second highest Primary completion rate (% of total enrollments) of High income?
Offer a very short reply. 0.04. What is the difference between the highest and the second highest Primary completion rate (% of total enrollments) in Botswana?
Your answer should be very brief. 0.01. What is the difference between the highest and the second highest Primary completion rate (% of total enrollments) of Egypt, Arab Rep.?
Ensure brevity in your answer.  1.42. What is the difference between the highest and the second highest Primary completion rate (% of total enrollments) of Kuwait?
Your answer should be very brief. 0.93. What is the difference between the highest and the lowest Primary completion rate (% of total enrollments) in High income?
Keep it short and to the point. 2.82. What is the difference between the highest and the lowest Primary completion rate (% of total enrollments) in Botswana?
Your response must be concise. 25.59. What is the difference between the highest and the lowest Primary completion rate (% of total enrollments) of Egypt, Arab Rep.?
Offer a very short reply. 38.26. What is the difference between the highest and the lowest Primary completion rate (% of total enrollments) of Kuwait?
Make the answer very short. 20.97. 